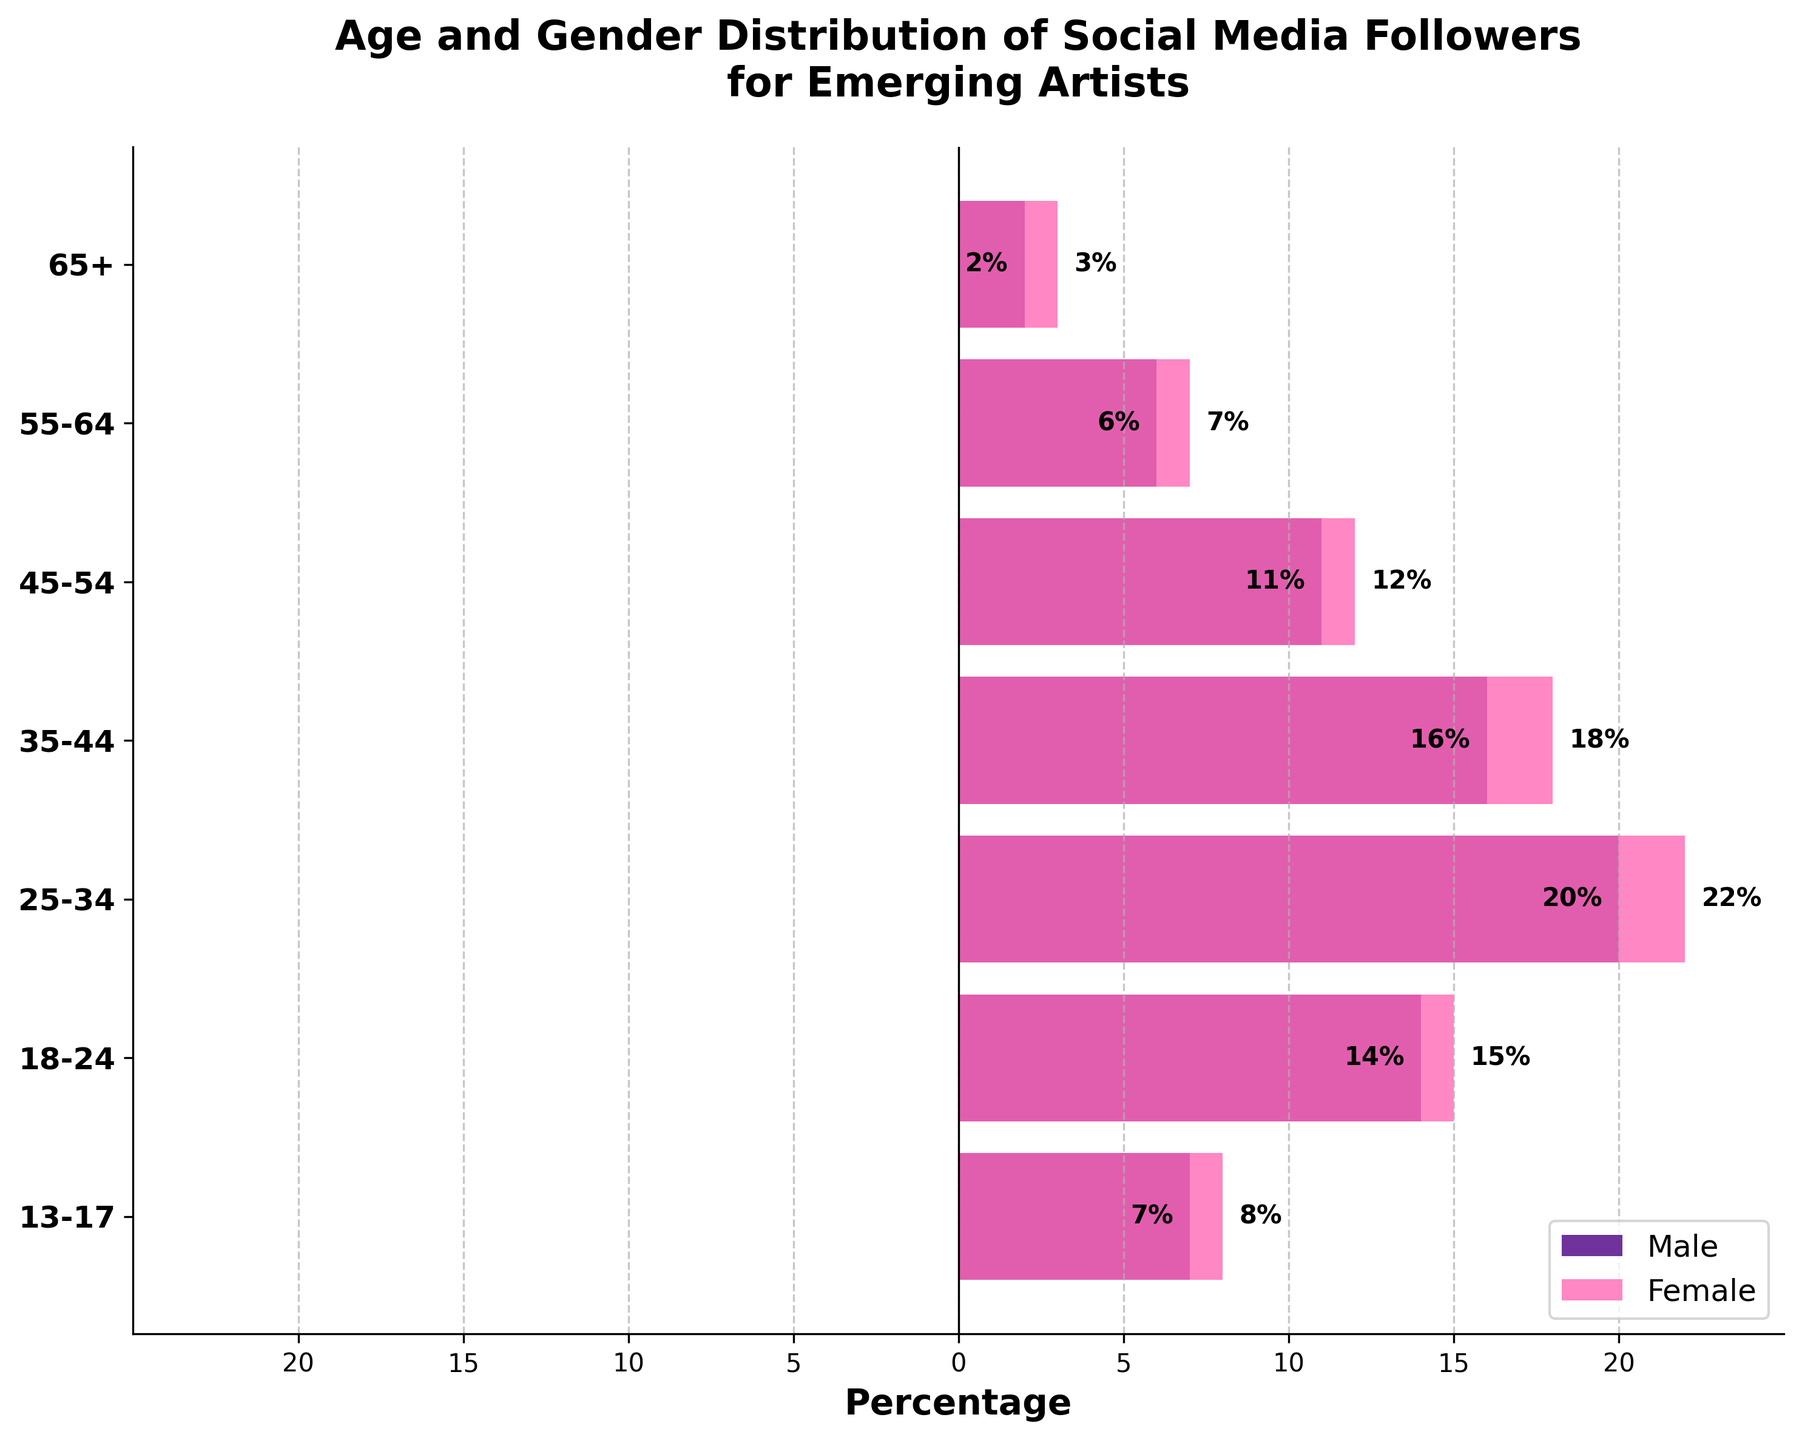How many age groups are represented in the figure? The figure has labels on the y-axis representing age groups. To find the number of age groups, count the labels. The age groups are 13-17, 18-24, 25-34, 35-44, 45-54, 55-64, and 65+. There are 7 labels, hence 7 age groups.
Answer: 7 What is the title of the figure? The title of the figure is presented at the top of the chart. It reads "Age and Gender Distribution of Social Media Followers for Emerging Artists".
Answer: Age and Gender Distribution of Social Media Followers for Emerging Artists Which age group has the highest percentage of male followers? To determine this, examine the lengths of the bars on the left side of the pyramid representing male followers. The longest bar corresponds to the 25-34 age group. The figure shows a -20% value for males in this group.
Answer: 25-34 How does the percentage of female followers aged 18-24 compare to that of female followers aged 35-44? Compare the length of the bars on the right side of the pyramid for these two age groups. The bar for the 18-24 age group is at 15%, and the bar for the 35-44 age group is at 18%. Thus, 18-24 is less than 35-44.
Answer: 18-24 is less than 35-44 What is the combined percentage of male and female followers in the 55-64 age group? Add the absolute values of the corresponding bars for both males and females in the 55-64 age group: Male is 6% and Female is 7%. Summing 6 + 7 gives 13%.
Answer: 13% Which gender has more followers in the 13-17 age group, and by how much? For the 13-17 age group, compare the percentages of male and female followers. Females are at 8% and males are at 7%. Subtracting 7 from 8 results in a difference of 1% more female followers.
Answer: Female by 1% What is the difference in the percentage of followers between the 45-54 and 65+ age groups for males? Compare the absolute values of male followers' percentages in the 45-54 and 65+ age groups. For 45-54, it’s 11%, and for 65+, it’s 2%. Subtract 2 from 11 to get 9%.
Answer: 9% Which age group has the smallest difference in the percentage of male and female followers? Calculate the difference for each age group: 13-17 (1%), 18-24 (1%), 25-34 (2%), 35-44 (2%), 45-54 (1%), 55-64 (1%), 65+ (1%). The smallest difference is 1%, which appears in multiple age groups (13-17, 18-24, 45-54, 55-64, 65+).
Answer: 13-17, 18-24, 45-54, 55-64, 65+ What percentage of followers falls into the 25-34 age group? Add the percentages of male and female followers for the 25-34 age group: Male is 20%, and Female is 22%. Adding 20 + 22 gives 42%.
Answer: 42% Considering the data, which gender has a higher overall percentage of followers? Sum the absolute values of the percentages for all age groups and compare totals: Males (7 + 14 + 20 + 16 + 11 + 6 + 2 = 76) and Females (8 + 15 + 22 + 18 + 12 + 7 + 3 = 85). Females have a higher total percentage.
Answer: Female 